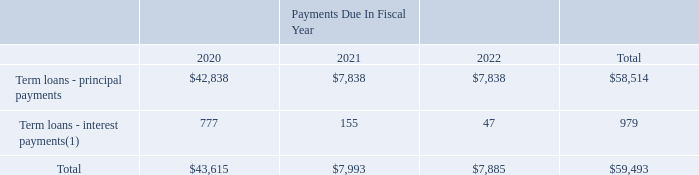FRT Term Loan
On October 25, 2019, we entered into a $23.4 million three-year credit facility loan agreement (the "FRT Term Loan") with HSBC Trinkaus & Burkhardt AG, Germany, to fund the acquisition of FRT GmbH, which we acquired on October 9, 2019. See Note 4 for further details of the acquisition.
The FRT Term Loan bears interest at a rate equal to the Euro Interbank Offered Rate ("EURIBOR") plus 1.75 % per annum and will be repaid in quarterly installments of approximately $1.9 million plus interest beginning January 25, 2020.
The obligations under the FRT Term Loan are fully and unconditionally guaranteed by FormFactor, Inc.
The Credit Facility contains negative covenants customary for financing of this type, including covenants that place limitations on the incurrence of additional indebtedness, the creation of liens, the payment of dividends; dispositions; fundamental changes, including mergers and acquisitions; loans and investments; sale leasebacks; negative pledges; transactions with affiliates; changes in fiscal year; sanctions and anti-bribery laws and regulations, and modifications to charter documents in a manner materially adverse to the Lenders.
The FRT Term Loan also contains affirmative covenants and representations and warranties customary for financing of this type.
Future principal and interest payments on our term loans as of December 28, 2019, based on the interest rate in effect at that date were as follows (in thousands):
(1) Represents our minimum interest payment commitments at 1.35% per annum for the FRT Term Loan and 3.71% per annum for the CMI Term Loan.
When was FRT GmbH acquired? October 9, 2019. What is the change in Term loans - principal payments from Fiscal Year 2021 to 2020?
Answer scale should be: thousand. 7,838-42,838
Answer: -35000. What is the change in Term loans - interest payments from Fiscal Year 2021 to 2020?
Answer scale should be: thousand. 155-777
Answer: -622. In which year was Term loans - principal payments less than 10,000 thousands? Locate and analyze term loans - principal payments in row 3
answer: 2021, 2022. What was the Term loans - interest payments in 2020, 2021 and 2022 respectively?
Answer scale should be: thousand. 777, 155, 47. What was the credit facility loan amount entered on October 25, 2019? $23.4 million. 